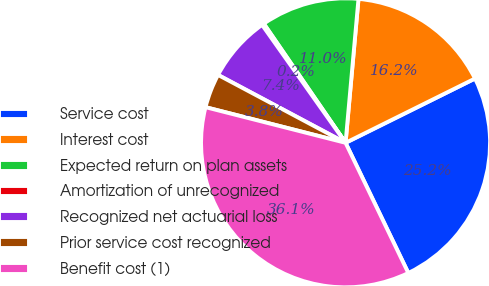Convert chart to OTSL. <chart><loc_0><loc_0><loc_500><loc_500><pie_chart><fcel>Service cost<fcel>Interest cost<fcel>Expected return on plan assets<fcel>Amortization of unrecognized<fcel>Recognized net actuarial loss<fcel>Prior service cost recognized<fcel>Benefit cost (1)<nl><fcel>25.19%<fcel>16.24%<fcel>11.0%<fcel>0.23%<fcel>7.41%<fcel>3.82%<fcel>36.12%<nl></chart> 